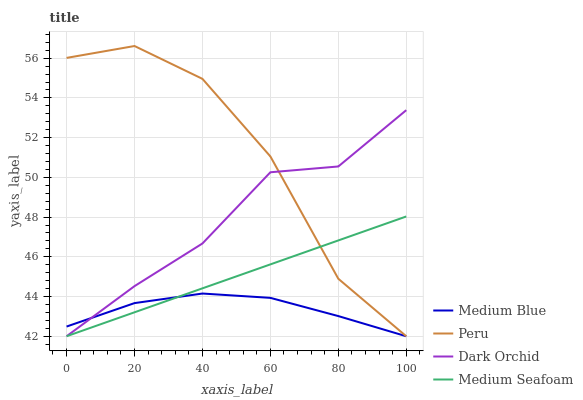Does Medium Blue have the minimum area under the curve?
Answer yes or no. Yes. Does Peru have the maximum area under the curve?
Answer yes or no. Yes. Does Dark Orchid have the minimum area under the curve?
Answer yes or no. No. Does Dark Orchid have the maximum area under the curve?
Answer yes or no. No. Is Medium Seafoam the smoothest?
Answer yes or no. Yes. Is Peru the roughest?
Answer yes or no. Yes. Is Dark Orchid the smoothest?
Answer yes or no. No. Is Dark Orchid the roughest?
Answer yes or no. No. Does Medium Blue have the lowest value?
Answer yes or no. Yes. Does Peru have the highest value?
Answer yes or no. Yes. Does Dark Orchid have the highest value?
Answer yes or no. No. Does Medium Seafoam intersect Dark Orchid?
Answer yes or no. Yes. Is Medium Seafoam less than Dark Orchid?
Answer yes or no. No. Is Medium Seafoam greater than Dark Orchid?
Answer yes or no. No. 